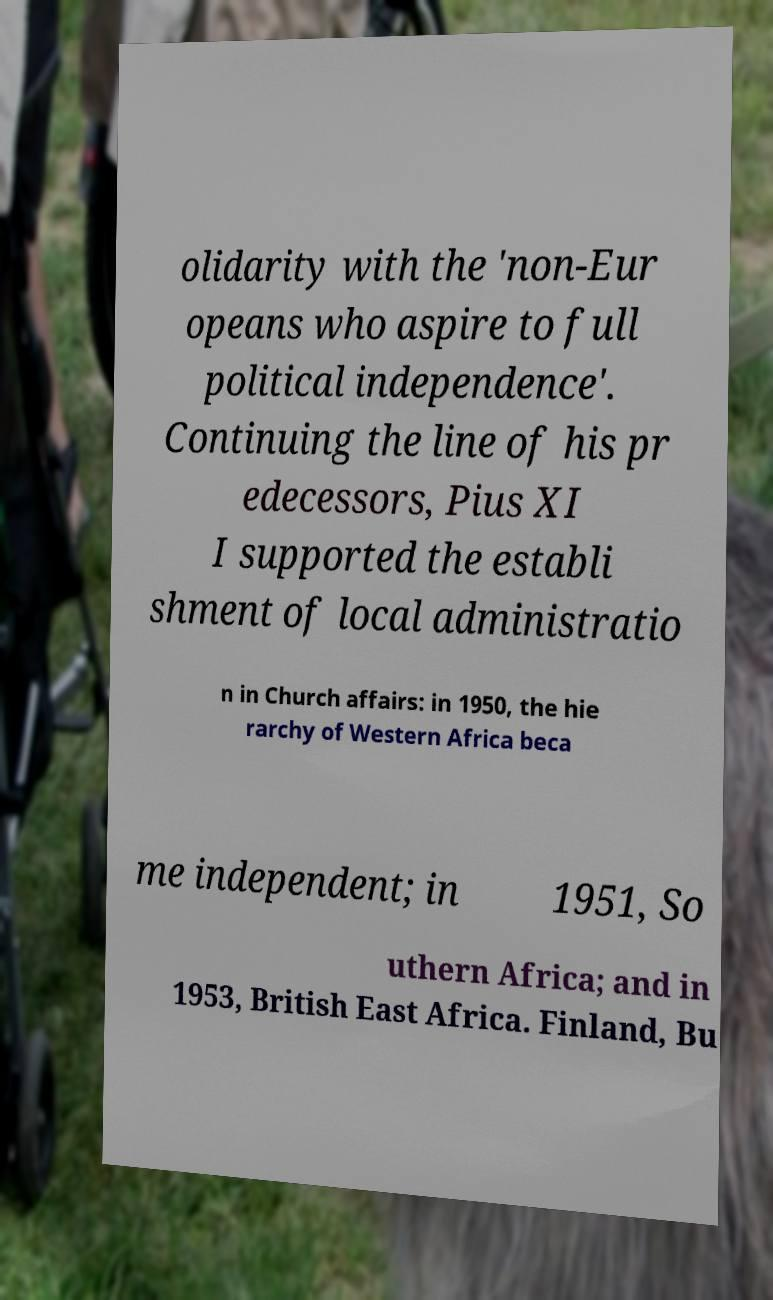Could you extract and type out the text from this image? olidarity with the 'non-Eur opeans who aspire to full political independence'. Continuing the line of his pr edecessors, Pius XI I supported the establi shment of local administratio n in Church affairs: in 1950, the hie rarchy of Western Africa beca me independent; in 1951, So uthern Africa; and in 1953, British East Africa. Finland, Bu 